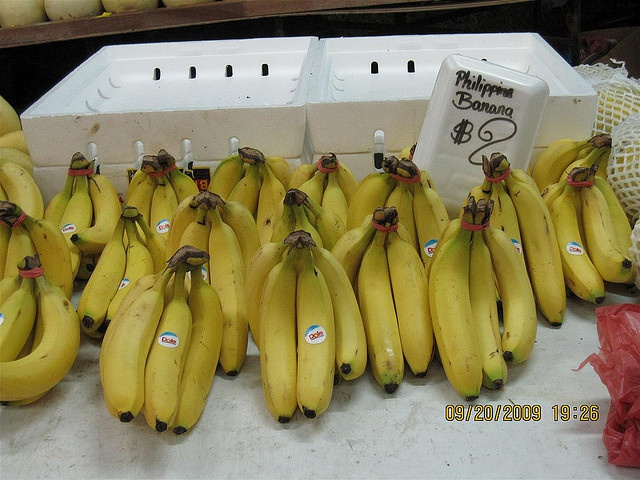Describe the objects in this image and their specific colors. I can see banana in tan and olive tones, banana in tan and olive tones, banana in tan and olive tones, banana in tan and olive tones, and banana in tan and olive tones in this image. 